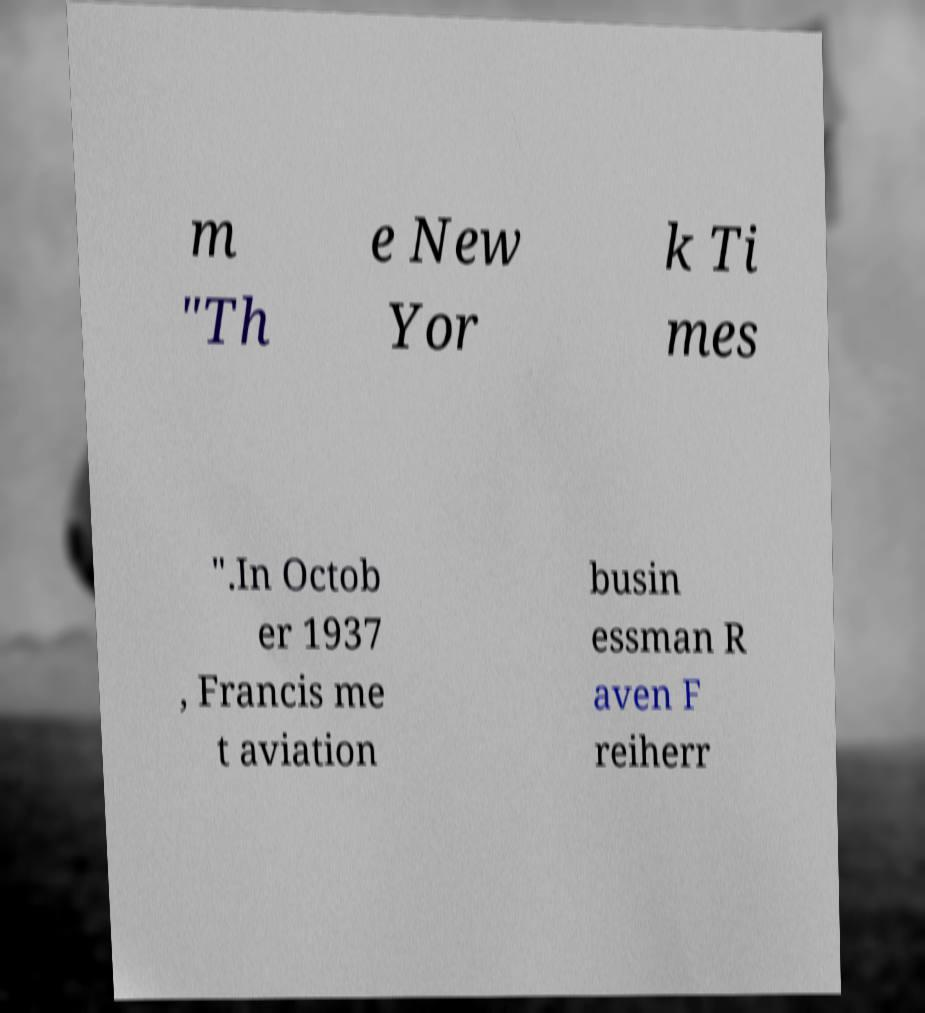Please read and relay the text visible in this image. What does it say? m "Th e New Yor k Ti mes ".In Octob er 1937 , Francis me t aviation busin essman R aven F reiherr 